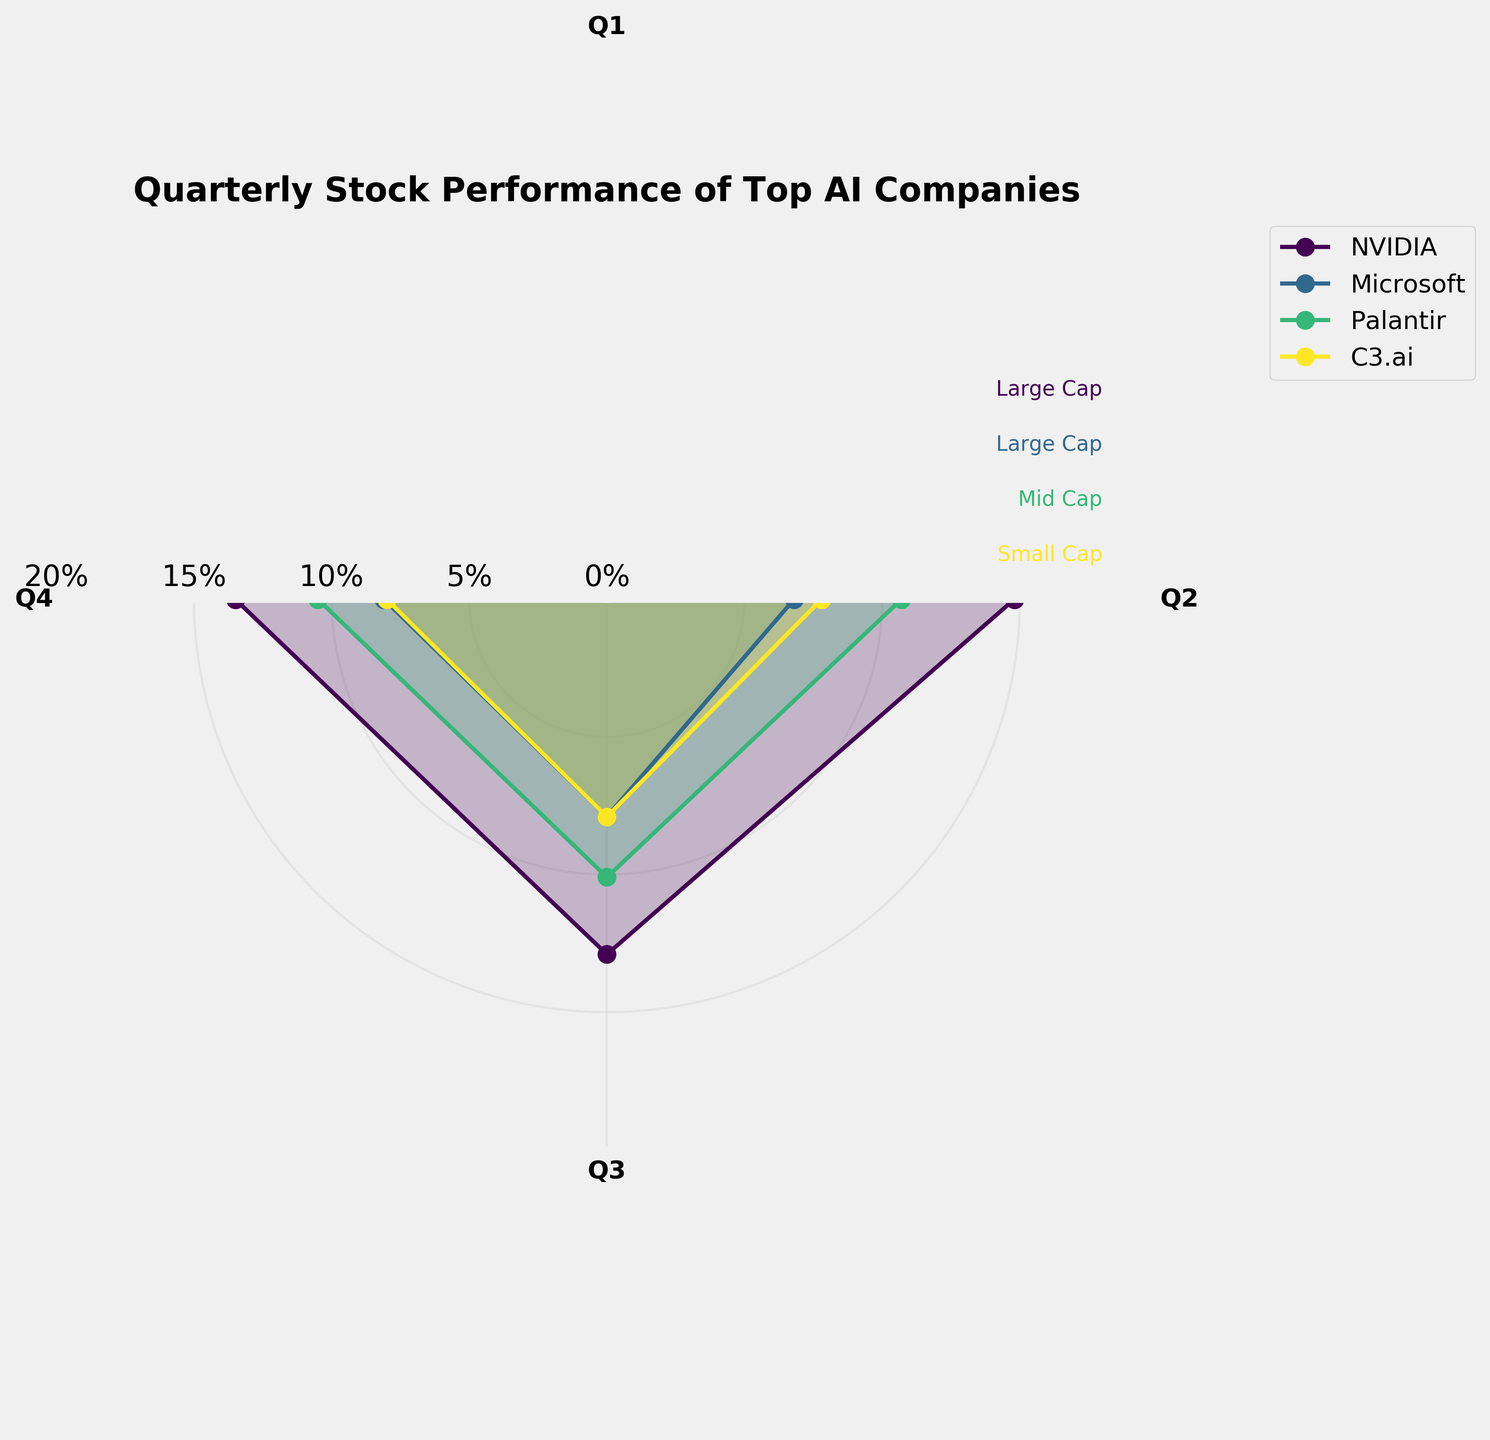What's the title of the figure? The title is usually prominently displayed above or near the top of the figure. For this particular rose chart, it's clearly labeled to describe the data it represents.
Answer: Quarterly Stock Performance of Top AI Companies Which AI company had the highest stock performance in Q1? You need to look at the segment labeled Q1 in the rose chart and identify the company with the highest percentage. NVIDIA shows the highest value in Q1.
Answer: NVIDIA How does Palantir's Q2 performance compare to its Q4 performance? To answer this, find Palantir's Q2 and Q4 segments and compare their lengths. Palantir had a Q2 performance of 10.7% and a Q4 performance of 10.5%. Therefore, Q2 is slightly higher.
Answer: Q2 is slightly higher What is the average quarterly stock performance for C3.ai? To calculate this, sum all quarterly performances for C3.ai (8.2%, 7.8%, 7.9%, 8.0%) and then divide by 4. The average is (8.2 + 7.8 + 7.9 + 8.0) / 4 = 8.0%.
Answer: 8.0% Which company showed the highest consistency in its quarterly performances? Consistency can be checked by small variations in performance between quarters. Palantir shows the closest values across all quarters (ranging from 10.1% to 11.4%), indicating the highest consistency.
Answer: Palantir Compare the stock performance of Microsoft and NVIDIA in Q3. Which one performed better? Locate the Q3 segments for both Microsoft and NVIDIA. Microsoft has a performance of 7.9% in Q3 while NVIDIA has 12.9%. Therefore, NVIDIA performed better.
Answer: NVIDIA What is the trend of Microsoft's stock performance across the quarters? To identify the trend, observe how the percentages for Microsoft change from Q1 to Q4. The trend shows increasing values: Q1 (7.3%), Q2 (6.8%), Q3 (7.9%), Q4 (8.1%). So, the performance generally improves over the quarters.
Answer: Increasing What is the difference between the highest and lowest quarterly performance for NVIDIA? Identify NVIDIA's highest value (15.2% in Q1) and the lowest value (12.9% in Q3) and calculate the difference: 15.2% - 12.9% = 2.3%.
Answer: 2.3% Which company belongs to the 'Small Cap' market capitalization category? As per the plot's annotations, identify the companies and their market cap sizes. C3.ai is labeled as Small Cap.
Answer: C3.ai What is the overall performance trend for Palantir from Q1 to Q4? Review Palantir's percentages from Q1 (11.4%) to Q4 (10.5%). Observing the trend, the performance slightly decreases: Q1 (11.4%), Q2 (10.7%), Q3 (10.1%), Q4 (10.5%).
Answer: Slightly decreasing 